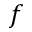Convert formula to latex. <formula><loc_0><loc_0><loc_500><loc_500>f</formula> 